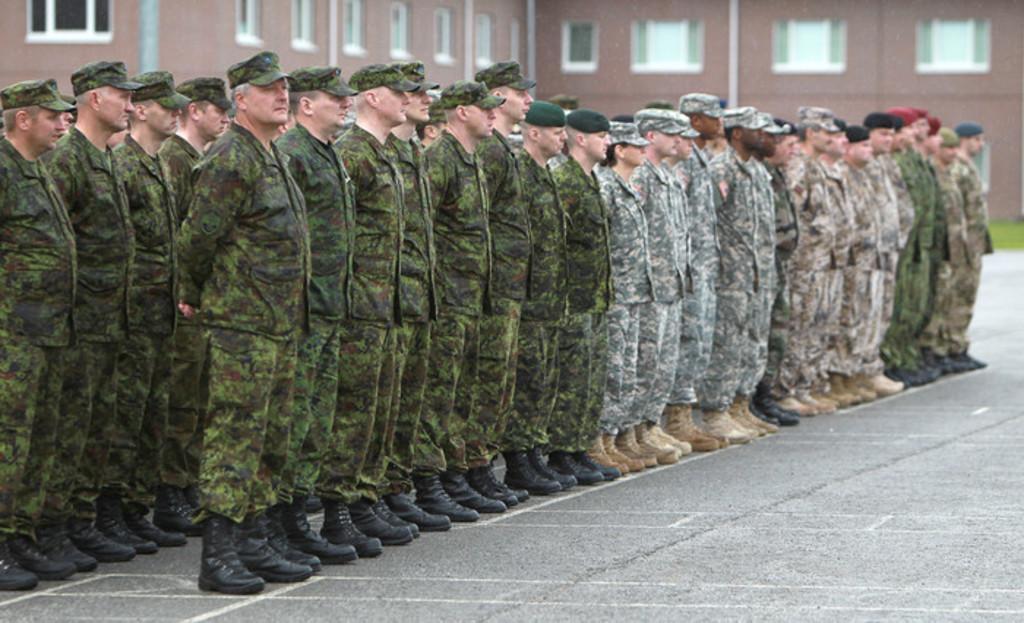In one or two sentences, can you explain what this image depicts? In this image we can see men standing in rows on the floor. In the background we can see buildings, windows and ground. 